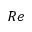Convert formula to latex. <formula><loc_0><loc_0><loc_500><loc_500>R e</formula> 